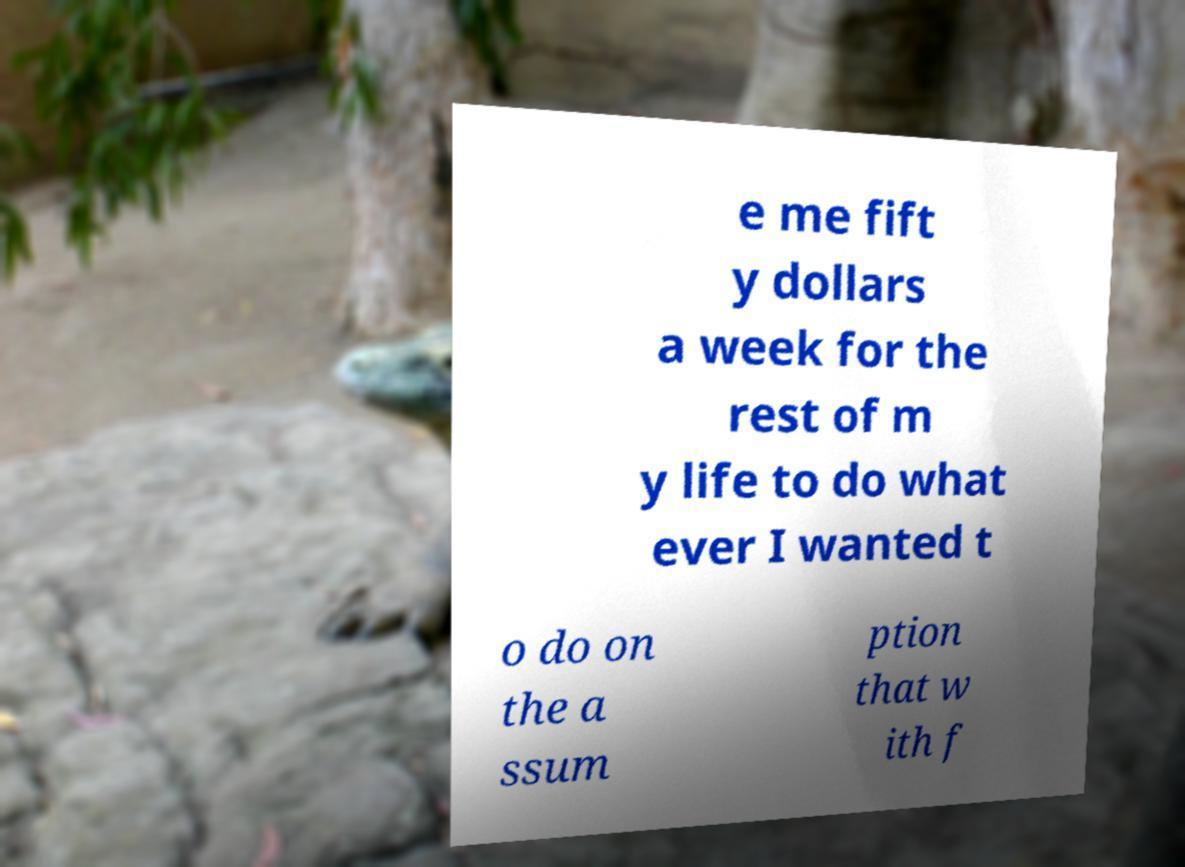What messages or text are displayed in this image? I need them in a readable, typed format. e me fift y dollars a week for the rest of m y life to do what ever I wanted t o do on the a ssum ption that w ith f 